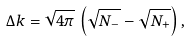<formula> <loc_0><loc_0><loc_500><loc_500>\Delta k = \sqrt { 4 \pi } \, \left ( \sqrt { N _ { - } } - \sqrt { N _ { + } } \right ) ,</formula> 